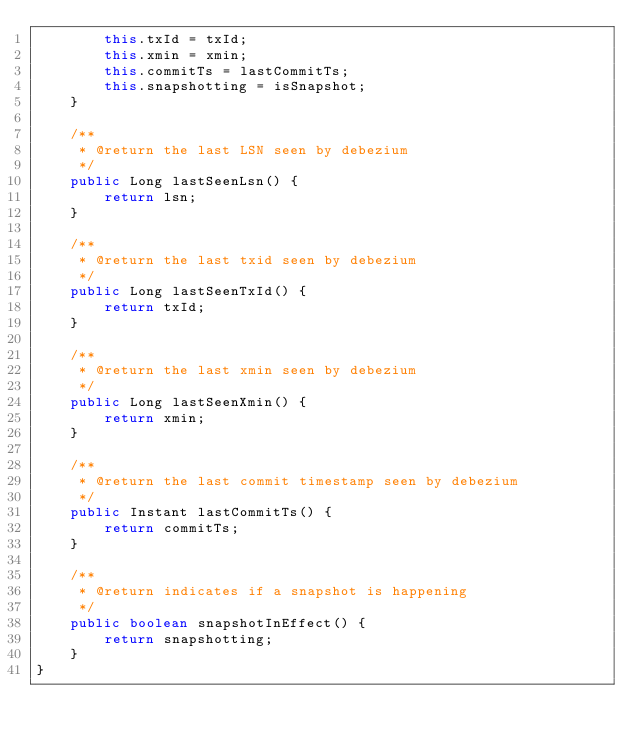Convert code to text. <code><loc_0><loc_0><loc_500><loc_500><_Java_>        this.txId = txId;
        this.xmin = xmin;
        this.commitTs = lastCommitTs;
        this.snapshotting = isSnapshot;
    }

    /**
     * @return the last LSN seen by debezium
     */
    public Long lastSeenLsn() {
        return lsn;
    }

    /**
     * @return the last txid seen by debezium
     */
    public Long lastSeenTxId() {
        return txId;
    }

    /**
     * @return the last xmin seen by debezium
     */
    public Long lastSeenXmin() {
        return xmin;
    }

    /**
     * @return the last commit timestamp seen by debezium
     */
    public Instant lastCommitTs() {
        return commitTs;
    }

    /**
     * @return indicates if a snapshot is happening
     */
    public boolean snapshotInEffect() {
        return snapshotting;
    }
}
</code> 